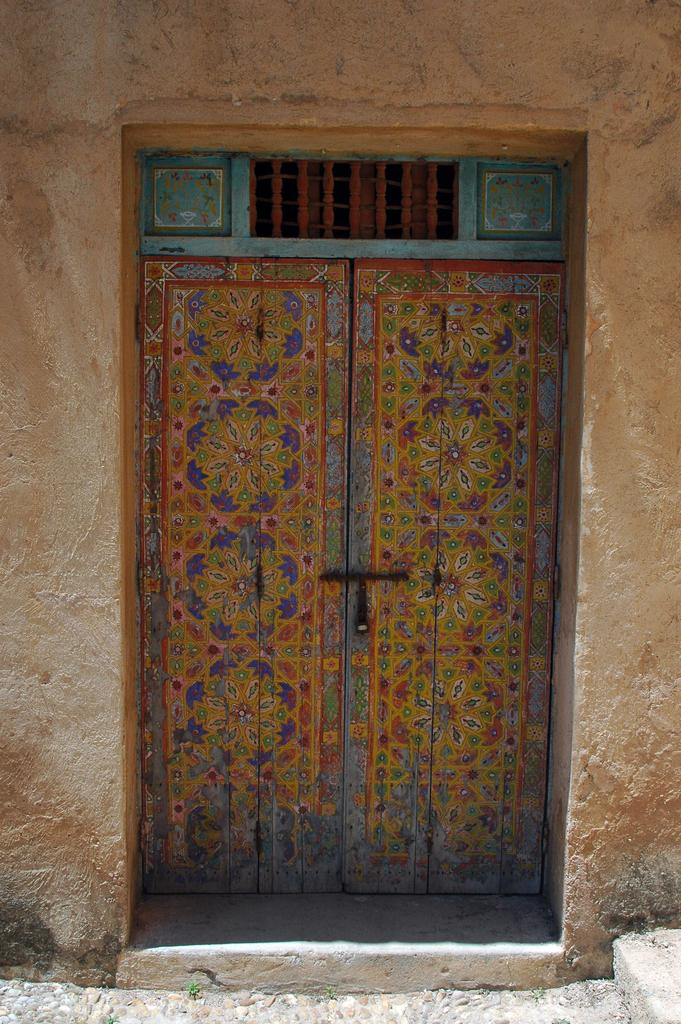What is the main subject in the center of the image? There is a door in the center of the image. What type of structure does the door belong to? The door belongs to a building. What type of precipitation can be seen falling from the sky in the image? There is no precipitation visible in the image; it only shows a door belonging to a building. 